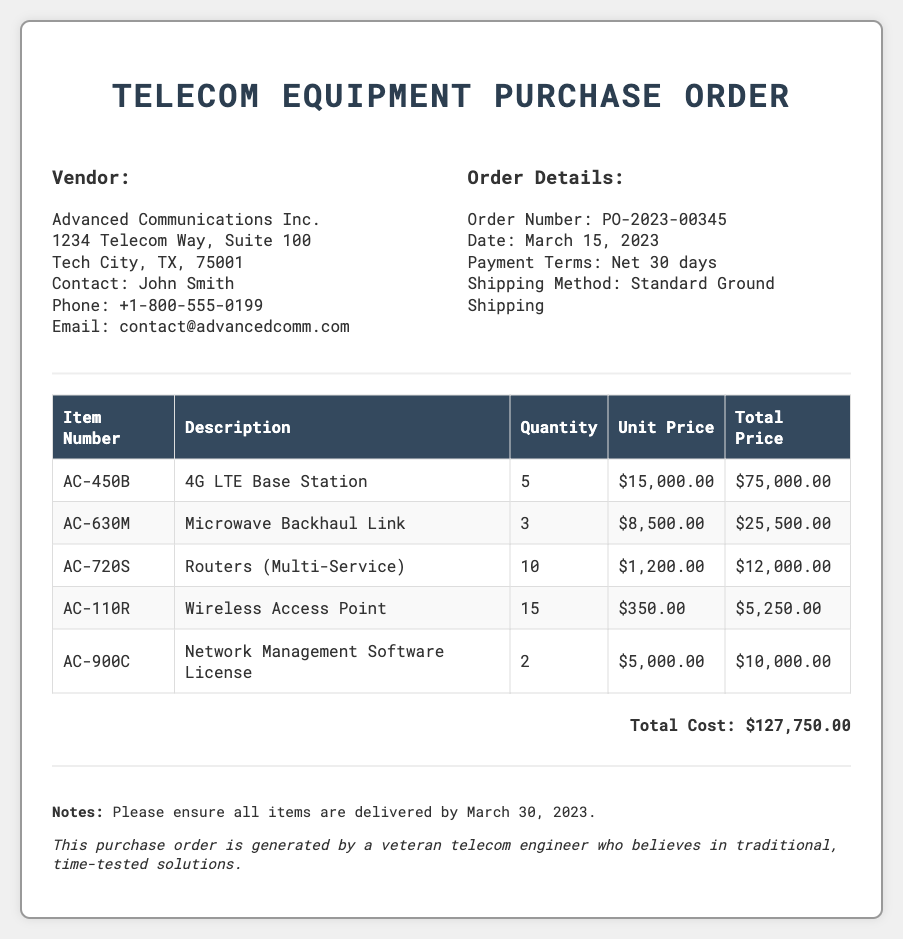What is the vendor name? The vendor name is mentioned in the vendor information section of the document.
Answer: Advanced Communications Inc What is the order number? The order number is stated in the order details section of the document.
Answer: PO-2023-00345 What is the total cost of the purchase order? The total cost is calculated based on the sum of all items listed in the document.
Answer: $127,750.00 How many Wireless Access Points are ordered? The quantity of Wireless Access Points is specified in the itemized list.
Answer: 15 What is the shipping method? The shipping method is detailed in the order information section of the document.
Answer: Standard Ground Shipping What is the payment term? The payment terms are described in the order information section.
Answer: Net 30 days What is the quantity of 4G LTE Base Stations ordered? The quantity of these base stations is listed under the itemized section of the document.
Answer: 5 By what date should the items be delivered? The delivery date is mentioned in the notes section of the document.
Answer: March 30, 2023 What is the unit price of a Microwave Backhaul Link? The unit price is presented in the itemized list of the document.
Answer: $8,500.00 